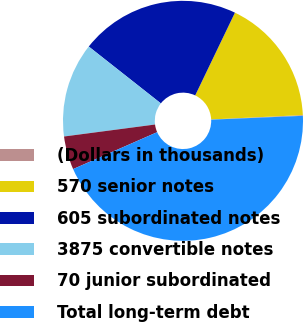Convert chart to OTSL. <chart><loc_0><loc_0><loc_500><loc_500><pie_chart><fcel>(Dollars in thousands)<fcel>570 senior notes<fcel>605 subordinated notes<fcel>3875 convertible notes<fcel>70 junior subordinated<fcel>Total long-term debt<nl><fcel>0.1%<fcel>17.11%<fcel>21.5%<fcel>12.71%<fcel>4.5%<fcel>44.08%<nl></chart> 